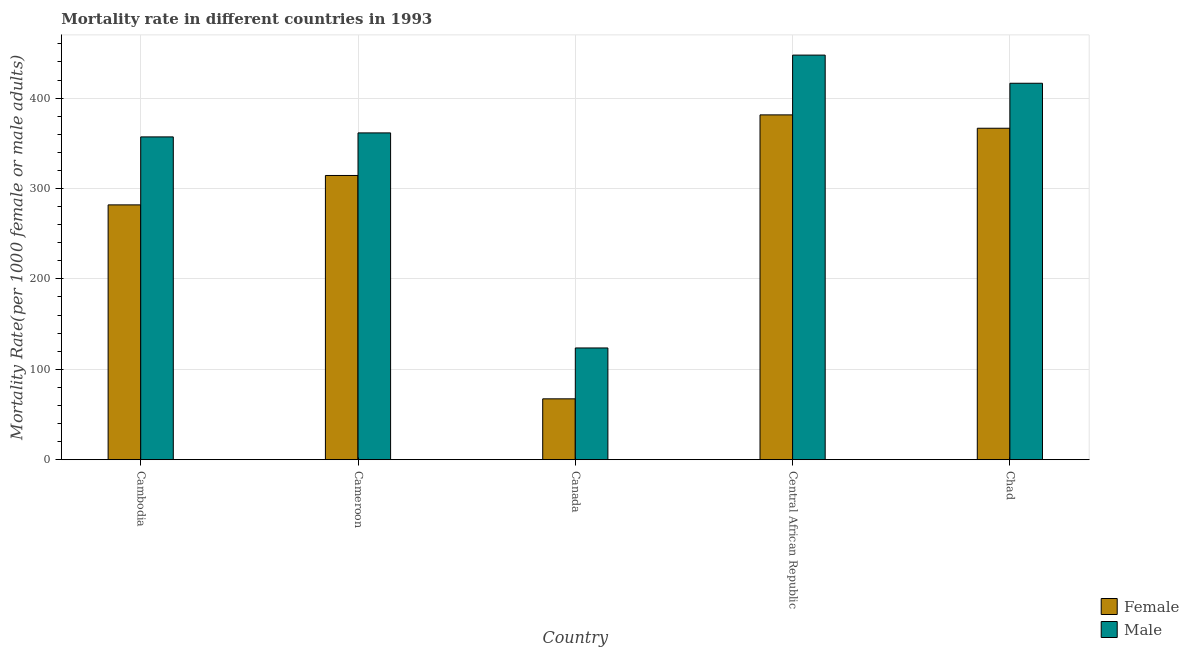How many groups of bars are there?
Give a very brief answer. 5. Are the number of bars on each tick of the X-axis equal?
Ensure brevity in your answer.  Yes. How many bars are there on the 5th tick from the left?
Provide a short and direct response. 2. What is the label of the 4th group of bars from the left?
Your response must be concise. Central African Republic. In how many cases, is the number of bars for a given country not equal to the number of legend labels?
Your answer should be very brief. 0. What is the female mortality rate in Canada?
Keep it short and to the point. 67.33. Across all countries, what is the maximum female mortality rate?
Give a very brief answer. 381.47. Across all countries, what is the minimum male mortality rate?
Make the answer very short. 123.61. In which country was the male mortality rate maximum?
Your answer should be very brief. Central African Republic. What is the total female mortality rate in the graph?
Your response must be concise. 1411.83. What is the difference between the female mortality rate in Cameroon and that in Central African Republic?
Your response must be concise. -67.04. What is the difference between the male mortality rate in Central African Republic and the female mortality rate in Cameroon?
Your answer should be very brief. 133.18. What is the average male mortality rate per country?
Offer a terse response. 341.26. What is the difference between the female mortality rate and male mortality rate in Cambodia?
Your response must be concise. -75.2. What is the ratio of the female mortality rate in Cameroon to that in Canada?
Your answer should be very brief. 4.67. What is the difference between the highest and the second highest female mortality rate?
Give a very brief answer. 14.77. What is the difference between the highest and the lowest male mortality rate?
Make the answer very short. 324. In how many countries, is the male mortality rate greater than the average male mortality rate taken over all countries?
Provide a succinct answer. 4. Is the sum of the female mortality rate in Cambodia and Cameroon greater than the maximum male mortality rate across all countries?
Provide a short and direct response. Yes. What does the 2nd bar from the left in Chad represents?
Ensure brevity in your answer.  Male. What does the 1st bar from the right in Cambodia represents?
Your answer should be very brief. Male. What is the difference between two consecutive major ticks on the Y-axis?
Provide a short and direct response. 100. Does the graph contain grids?
Your answer should be compact. Yes. Where does the legend appear in the graph?
Your answer should be compact. Bottom right. How many legend labels are there?
Offer a terse response. 2. How are the legend labels stacked?
Give a very brief answer. Vertical. What is the title of the graph?
Provide a succinct answer. Mortality rate in different countries in 1993. Does "Fertility rate" appear as one of the legend labels in the graph?
Make the answer very short. No. What is the label or title of the X-axis?
Your answer should be compact. Country. What is the label or title of the Y-axis?
Make the answer very short. Mortality Rate(per 1000 female or male adults). What is the Mortality Rate(per 1000 female or male adults) in Female in Cambodia?
Your answer should be compact. 281.91. What is the Mortality Rate(per 1000 female or male adults) in Male in Cambodia?
Give a very brief answer. 357.11. What is the Mortality Rate(per 1000 female or male adults) of Female in Cameroon?
Your answer should be very brief. 314.43. What is the Mortality Rate(per 1000 female or male adults) in Male in Cameroon?
Offer a very short reply. 361.54. What is the Mortality Rate(per 1000 female or male adults) of Female in Canada?
Ensure brevity in your answer.  67.33. What is the Mortality Rate(per 1000 female or male adults) of Male in Canada?
Provide a short and direct response. 123.61. What is the Mortality Rate(per 1000 female or male adults) of Female in Central African Republic?
Offer a very short reply. 381.47. What is the Mortality Rate(per 1000 female or male adults) in Male in Central African Republic?
Your answer should be very brief. 447.61. What is the Mortality Rate(per 1000 female or male adults) in Female in Chad?
Your answer should be compact. 366.7. What is the Mortality Rate(per 1000 female or male adults) in Male in Chad?
Offer a very short reply. 416.46. Across all countries, what is the maximum Mortality Rate(per 1000 female or male adults) of Female?
Keep it short and to the point. 381.47. Across all countries, what is the maximum Mortality Rate(per 1000 female or male adults) in Male?
Your response must be concise. 447.61. Across all countries, what is the minimum Mortality Rate(per 1000 female or male adults) of Female?
Give a very brief answer. 67.33. Across all countries, what is the minimum Mortality Rate(per 1000 female or male adults) of Male?
Your answer should be compact. 123.61. What is the total Mortality Rate(per 1000 female or male adults) of Female in the graph?
Make the answer very short. 1411.83. What is the total Mortality Rate(per 1000 female or male adults) in Male in the graph?
Offer a terse response. 1706.32. What is the difference between the Mortality Rate(per 1000 female or male adults) of Female in Cambodia and that in Cameroon?
Offer a terse response. -32.52. What is the difference between the Mortality Rate(per 1000 female or male adults) of Male in Cambodia and that in Cameroon?
Offer a very short reply. -4.42. What is the difference between the Mortality Rate(per 1000 female or male adults) of Female in Cambodia and that in Canada?
Provide a short and direct response. 214.59. What is the difference between the Mortality Rate(per 1000 female or male adults) of Male in Cambodia and that in Canada?
Your response must be concise. 233.51. What is the difference between the Mortality Rate(per 1000 female or male adults) in Female in Cambodia and that in Central African Republic?
Provide a short and direct response. -99.55. What is the difference between the Mortality Rate(per 1000 female or male adults) of Male in Cambodia and that in Central African Republic?
Keep it short and to the point. -90.49. What is the difference between the Mortality Rate(per 1000 female or male adults) in Female in Cambodia and that in Chad?
Your answer should be compact. -84.79. What is the difference between the Mortality Rate(per 1000 female or male adults) of Male in Cambodia and that in Chad?
Give a very brief answer. -59.34. What is the difference between the Mortality Rate(per 1000 female or male adults) of Female in Cameroon and that in Canada?
Provide a succinct answer. 247.1. What is the difference between the Mortality Rate(per 1000 female or male adults) in Male in Cameroon and that in Canada?
Ensure brevity in your answer.  237.93. What is the difference between the Mortality Rate(per 1000 female or male adults) in Female in Cameroon and that in Central African Republic?
Offer a very short reply. -67.04. What is the difference between the Mortality Rate(per 1000 female or male adults) in Male in Cameroon and that in Central African Republic?
Ensure brevity in your answer.  -86.07. What is the difference between the Mortality Rate(per 1000 female or male adults) of Female in Cameroon and that in Chad?
Your response must be concise. -52.27. What is the difference between the Mortality Rate(per 1000 female or male adults) in Male in Cameroon and that in Chad?
Give a very brief answer. -54.92. What is the difference between the Mortality Rate(per 1000 female or male adults) in Female in Canada and that in Central African Republic?
Your answer should be compact. -314.14. What is the difference between the Mortality Rate(per 1000 female or male adults) in Male in Canada and that in Central African Republic?
Give a very brief answer. -324. What is the difference between the Mortality Rate(per 1000 female or male adults) of Female in Canada and that in Chad?
Offer a terse response. -299.37. What is the difference between the Mortality Rate(per 1000 female or male adults) of Male in Canada and that in Chad?
Your answer should be very brief. -292.85. What is the difference between the Mortality Rate(per 1000 female or male adults) of Female in Central African Republic and that in Chad?
Your answer should be compact. 14.77. What is the difference between the Mortality Rate(per 1000 female or male adults) of Male in Central African Republic and that in Chad?
Keep it short and to the point. 31.15. What is the difference between the Mortality Rate(per 1000 female or male adults) in Female in Cambodia and the Mortality Rate(per 1000 female or male adults) in Male in Cameroon?
Offer a very short reply. -79.62. What is the difference between the Mortality Rate(per 1000 female or male adults) of Female in Cambodia and the Mortality Rate(per 1000 female or male adults) of Male in Canada?
Offer a terse response. 158.3. What is the difference between the Mortality Rate(per 1000 female or male adults) of Female in Cambodia and the Mortality Rate(per 1000 female or male adults) of Male in Central African Republic?
Keep it short and to the point. -165.69. What is the difference between the Mortality Rate(per 1000 female or male adults) of Female in Cambodia and the Mortality Rate(per 1000 female or male adults) of Male in Chad?
Keep it short and to the point. -134.55. What is the difference between the Mortality Rate(per 1000 female or male adults) in Female in Cameroon and the Mortality Rate(per 1000 female or male adults) in Male in Canada?
Ensure brevity in your answer.  190.82. What is the difference between the Mortality Rate(per 1000 female or male adults) of Female in Cameroon and the Mortality Rate(per 1000 female or male adults) of Male in Central African Republic?
Give a very brief answer. -133.18. What is the difference between the Mortality Rate(per 1000 female or male adults) in Female in Cameroon and the Mortality Rate(per 1000 female or male adults) in Male in Chad?
Make the answer very short. -102.03. What is the difference between the Mortality Rate(per 1000 female or male adults) in Female in Canada and the Mortality Rate(per 1000 female or male adults) in Male in Central African Republic?
Provide a short and direct response. -380.28. What is the difference between the Mortality Rate(per 1000 female or male adults) in Female in Canada and the Mortality Rate(per 1000 female or male adults) in Male in Chad?
Give a very brief answer. -349.13. What is the difference between the Mortality Rate(per 1000 female or male adults) in Female in Central African Republic and the Mortality Rate(per 1000 female or male adults) in Male in Chad?
Keep it short and to the point. -34.99. What is the average Mortality Rate(per 1000 female or male adults) in Female per country?
Make the answer very short. 282.37. What is the average Mortality Rate(per 1000 female or male adults) of Male per country?
Provide a short and direct response. 341.26. What is the difference between the Mortality Rate(per 1000 female or male adults) of Female and Mortality Rate(per 1000 female or male adults) of Male in Cambodia?
Offer a terse response. -75.2. What is the difference between the Mortality Rate(per 1000 female or male adults) of Female and Mortality Rate(per 1000 female or male adults) of Male in Cameroon?
Offer a terse response. -47.11. What is the difference between the Mortality Rate(per 1000 female or male adults) of Female and Mortality Rate(per 1000 female or male adults) of Male in Canada?
Your answer should be very brief. -56.28. What is the difference between the Mortality Rate(per 1000 female or male adults) of Female and Mortality Rate(per 1000 female or male adults) of Male in Central African Republic?
Your answer should be very brief. -66.14. What is the difference between the Mortality Rate(per 1000 female or male adults) in Female and Mortality Rate(per 1000 female or male adults) in Male in Chad?
Provide a short and direct response. -49.76. What is the ratio of the Mortality Rate(per 1000 female or male adults) of Female in Cambodia to that in Cameroon?
Make the answer very short. 0.9. What is the ratio of the Mortality Rate(per 1000 female or male adults) in Female in Cambodia to that in Canada?
Your response must be concise. 4.19. What is the ratio of the Mortality Rate(per 1000 female or male adults) in Male in Cambodia to that in Canada?
Make the answer very short. 2.89. What is the ratio of the Mortality Rate(per 1000 female or male adults) in Female in Cambodia to that in Central African Republic?
Offer a terse response. 0.74. What is the ratio of the Mortality Rate(per 1000 female or male adults) in Male in Cambodia to that in Central African Republic?
Provide a short and direct response. 0.8. What is the ratio of the Mortality Rate(per 1000 female or male adults) in Female in Cambodia to that in Chad?
Ensure brevity in your answer.  0.77. What is the ratio of the Mortality Rate(per 1000 female or male adults) of Male in Cambodia to that in Chad?
Ensure brevity in your answer.  0.86. What is the ratio of the Mortality Rate(per 1000 female or male adults) in Female in Cameroon to that in Canada?
Offer a terse response. 4.67. What is the ratio of the Mortality Rate(per 1000 female or male adults) in Male in Cameroon to that in Canada?
Keep it short and to the point. 2.92. What is the ratio of the Mortality Rate(per 1000 female or male adults) of Female in Cameroon to that in Central African Republic?
Make the answer very short. 0.82. What is the ratio of the Mortality Rate(per 1000 female or male adults) of Male in Cameroon to that in Central African Republic?
Offer a terse response. 0.81. What is the ratio of the Mortality Rate(per 1000 female or male adults) of Female in Cameroon to that in Chad?
Your answer should be very brief. 0.86. What is the ratio of the Mortality Rate(per 1000 female or male adults) of Male in Cameroon to that in Chad?
Ensure brevity in your answer.  0.87. What is the ratio of the Mortality Rate(per 1000 female or male adults) in Female in Canada to that in Central African Republic?
Give a very brief answer. 0.18. What is the ratio of the Mortality Rate(per 1000 female or male adults) of Male in Canada to that in Central African Republic?
Offer a very short reply. 0.28. What is the ratio of the Mortality Rate(per 1000 female or male adults) in Female in Canada to that in Chad?
Ensure brevity in your answer.  0.18. What is the ratio of the Mortality Rate(per 1000 female or male adults) in Male in Canada to that in Chad?
Provide a succinct answer. 0.3. What is the ratio of the Mortality Rate(per 1000 female or male adults) of Female in Central African Republic to that in Chad?
Give a very brief answer. 1.04. What is the ratio of the Mortality Rate(per 1000 female or male adults) in Male in Central African Republic to that in Chad?
Ensure brevity in your answer.  1.07. What is the difference between the highest and the second highest Mortality Rate(per 1000 female or male adults) in Female?
Keep it short and to the point. 14.77. What is the difference between the highest and the second highest Mortality Rate(per 1000 female or male adults) of Male?
Offer a very short reply. 31.15. What is the difference between the highest and the lowest Mortality Rate(per 1000 female or male adults) of Female?
Offer a very short reply. 314.14. What is the difference between the highest and the lowest Mortality Rate(per 1000 female or male adults) of Male?
Offer a terse response. 324. 